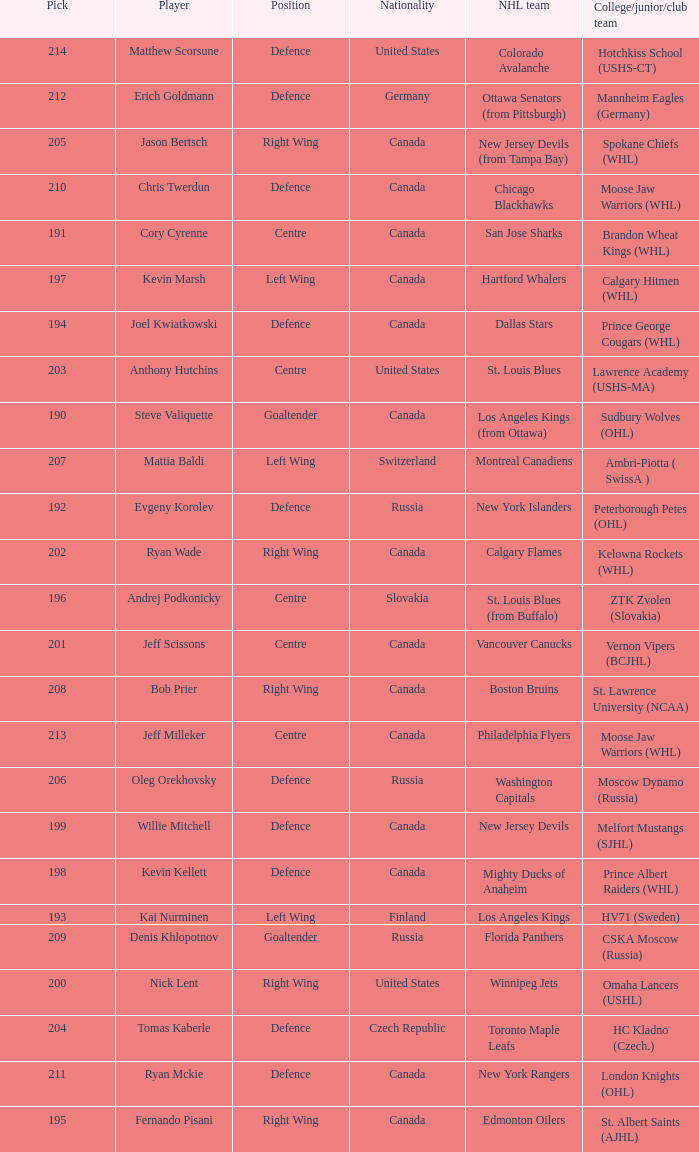Name the college for andrej podkonicky ZTK Zvolen (Slovakia). 